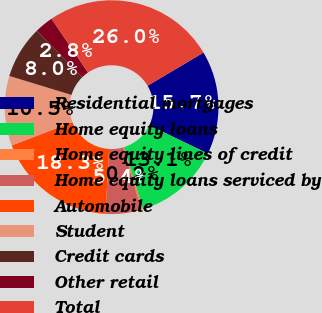Convert chart to OTSL. <chart><loc_0><loc_0><loc_500><loc_500><pie_chart><fcel>Residential mortgages<fcel>Home equity loans<fcel>Home equity lines of credit<fcel>Home equity loans serviced by<fcel>Automobile<fcel>Student<fcel>Credit cards<fcel>Other retail<fcel>Total<nl><fcel>15.68%<fcel>13.11%<fcel>0.25%<fcel>5.4%<fcel>18.26%<fcel>10.54%<fcel>7.97%<fcel>2.82%<fcel>25.97%<nl></chart> 